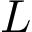<formula> <loc_0><loc_0><loc_500><loc_500>L</formula> 